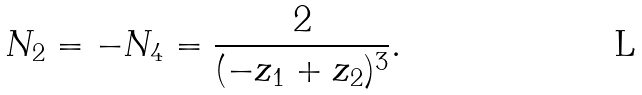Convert formula to latex. <formula><loc_0><loc_0><loc_500><loc_500>N _ { 2 } = - N _ { 4 } = \frac { 2 } { ( - z _ { 1 } + z _ { 2 } ) ^ { 3 } } .</formula> 